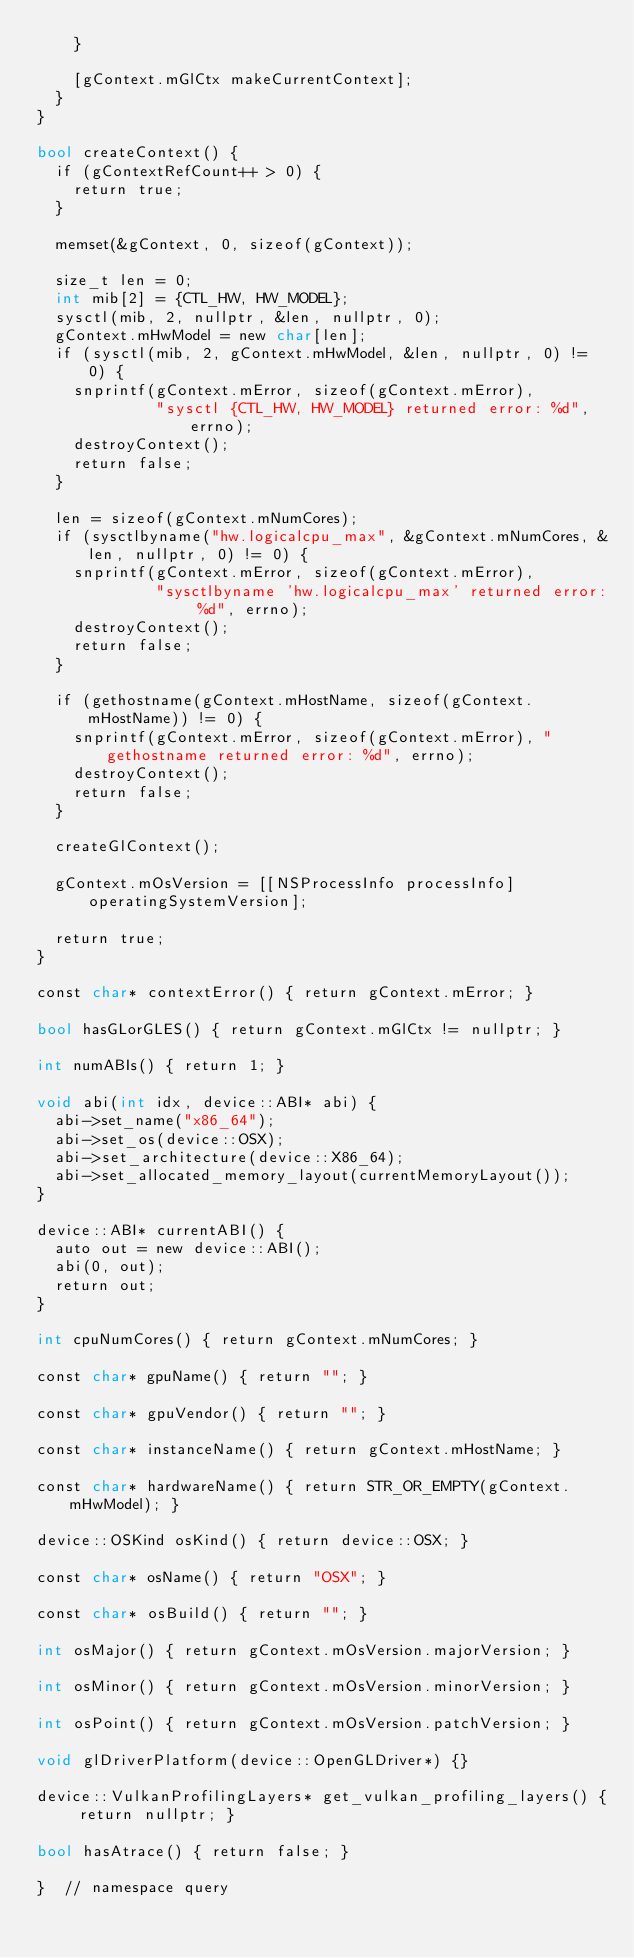Convert code to text. <code><loc_0><loc_0><loc_500><loc_500><_ObjectiveC_>    }

    [gContext.mGlCtx makeCurrentContext];
  }
}

bool createContext() {
  if (gContextRefCount++ > 0) {
    return true;
  }

  memset(&gContext, 0, sizeof(gContext));

  size_t len = 0;
  int mib[2] = {CTL_HW, HW_MODEL};
  sysctl(mib, 2, nullptr, &len, nullptr, 0);
  gContext.mHwModel = new char[len];
  if (sysctl(mib, 2, gContext.mHwModel, &len, nullptr, 0) != 0) {
    snprintf(gContext.mError, sizeof(gContext.mError),
             "sysctl {CTL_HW, HW_MODEL} returned error: %d", errno);
    destroyContext();
    return false;
  }

  len = sizeof(gContext.mNumCores);
  if (sysctlbyname("hw.logicalcpu_max", &gContext.mNumCores, &len, nullptr, 0) != 0) {
    snprintf(gContext.mError, sizeof(gContext.mError),
             "sysctlbyname 'hw.logicalcpu_max' returned error: %d", errno);
    destroyContext();
    return false;
  }

  if (gethostname(gContext.mHostName, sizeof(gContext.mHostName)) != 0) {
    snprintf(gContext.mError, sizeof(gContext.mError), "gethostname returned error: %d", errno);
    destroyContext();
    return false;
  }

  createGlContext();

  gContext.mOsVersion = [[NSProcessInfo processInfo] operatingSystemVersion];

  return true;
}

const char* contextError() { return gContext.mError; }

bool hasGLorGLES() { return gContext.mGlCtx != nullptr; }

int numABIs() { return 1; }

void abi(int idx, device::ABI* abi) {
  abi->set_name("x86_64");
  abi->set_os(device::OSX);
  abi->set_architecture(device::X86_64);
  abi->set_allocated_memory_layout(currentMemoryLayout());
}

device::ABI* currentABI() {
  auto out = new device::ABI();
  abi(0, out);
  return out;
}

int cpuNumCores() { return gContext.mNumCores; }

const char* gpuName() { return ""; }

const char* gpuVendor() { return ""; }

const char* instanceName() { return gContext.mHostName; }

const char* hardwareName() { return STR_OR_EMPTY(gContext.mHwModel); }

device::OSKind osKind() { return device::OSX; }

const char* osName() { return "OSX"; }

const char* osBuild() { return ""; }

int osMajor() { return gContext.mOsVersion.majorVersion; }

int osMinor() { return gContext.mOsVersion.minorVersion; }

int osPoint() { return gContext.mOsVersion.patchVersion; }

void glDriverPlatform(device::OpenGLDriver*) {}

device::VulkanProfilingLayers* get_vulkan_profiling_layers() { return nullptr; }

bool hasAtrace() { return false; }

}  // namespace query
</code> 